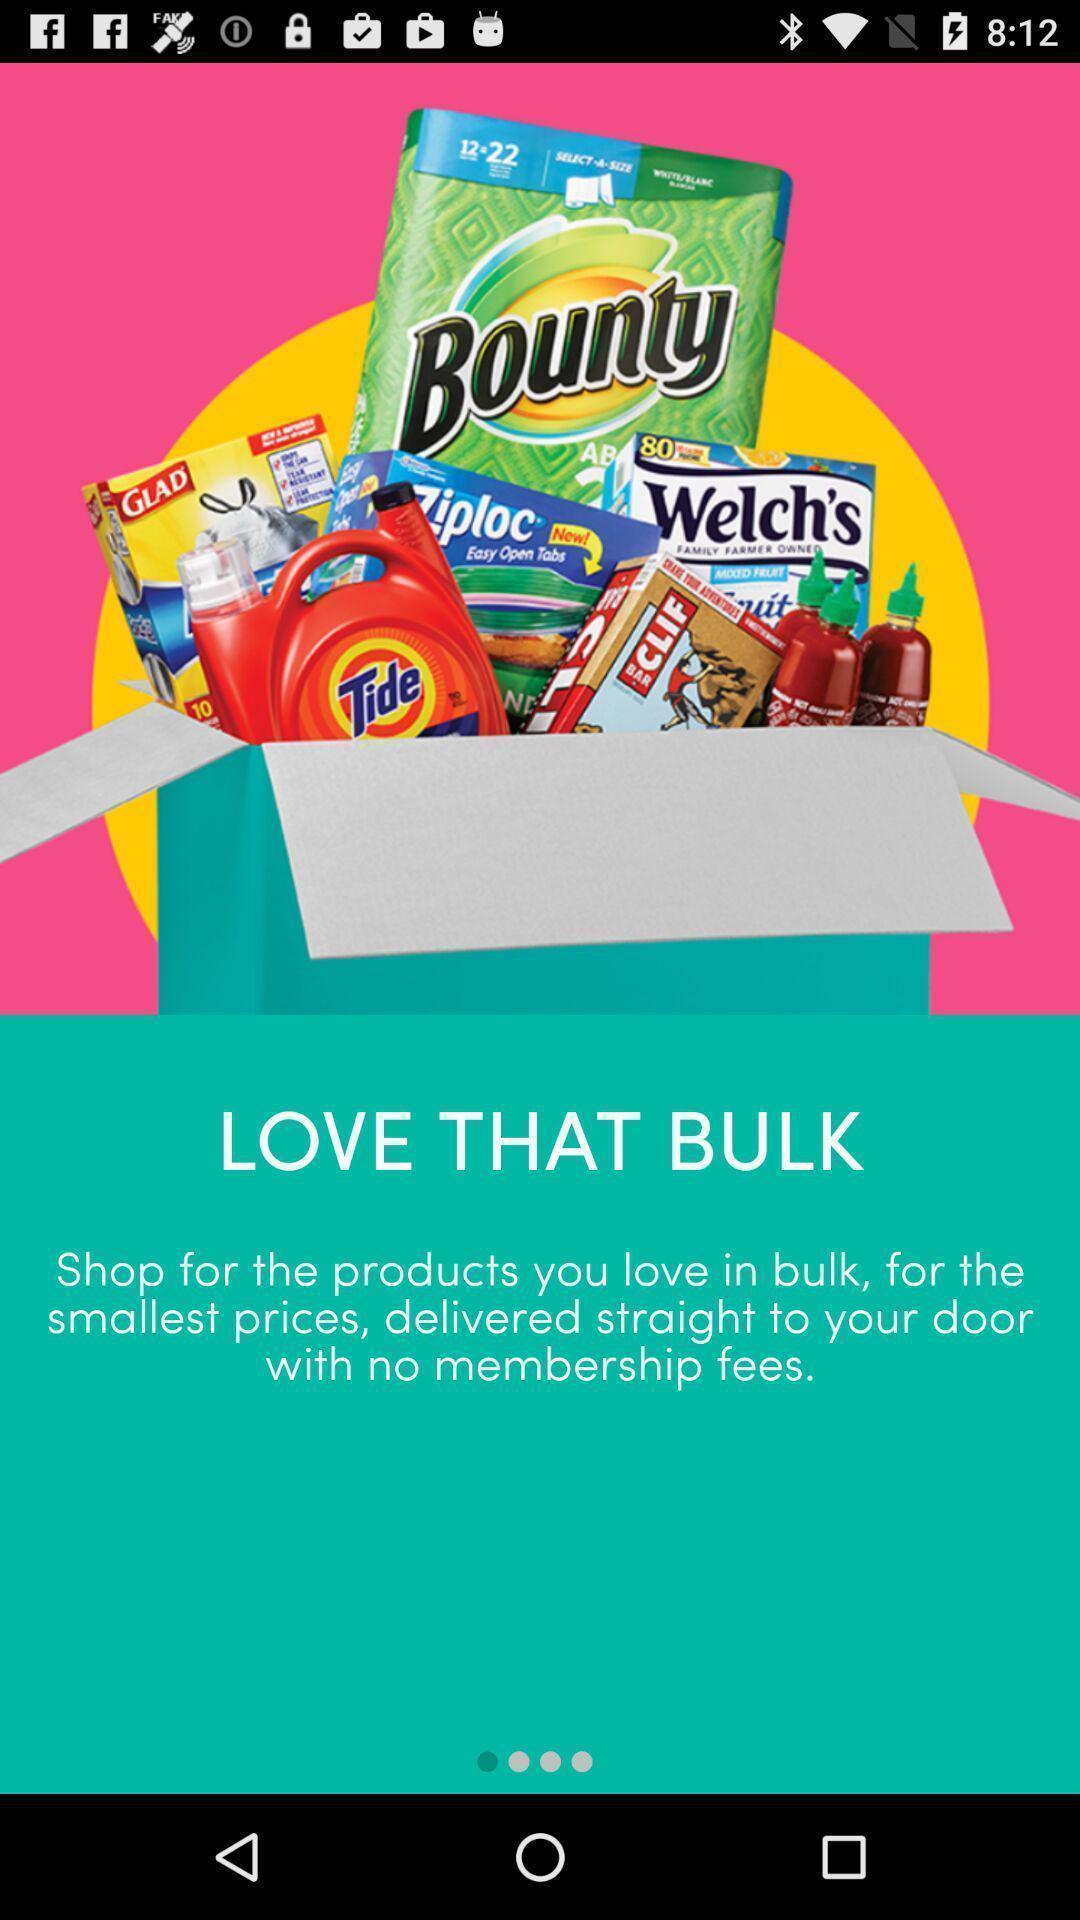Provide a description of this screenshot. Welcome page displayed of an online shopping application. 